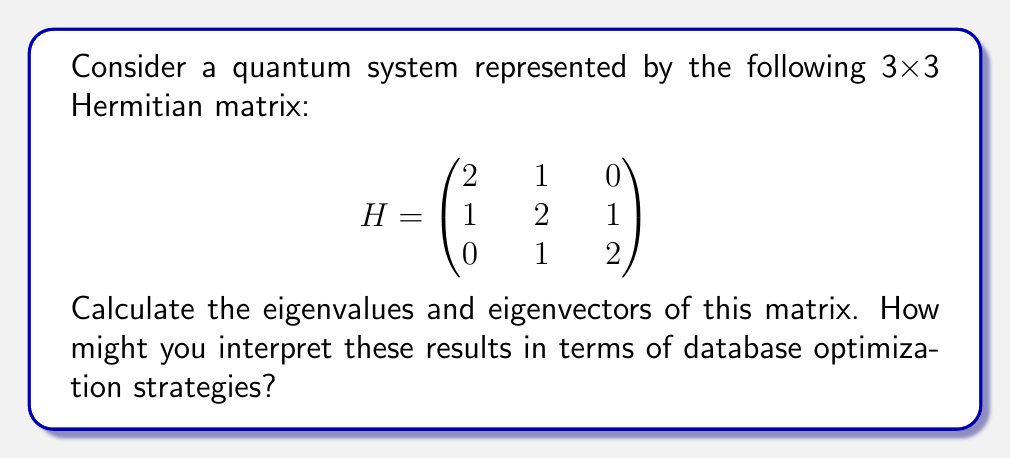Show me your answer to this math problem. To find the eigenvalues and eigenvectors, we'll follow these steps:

1) Find the characteristic equation:
   $\det(H - \lambda I) = 0$

   $$\begin{vmatrix}
   2-\lambda & 1 & 0 \\
   1 & 2-\lambda & 1 \\
   0 & 1 & 2-\lambda
   \end{vmatrix} = 0$$

2) Expand the determinant:
   $(2-\lambda)[(2-\lambda)^2 - 1] - 1(1-0) = 0$
   $(2-\lambda)[(2-\lambda)^2 - 1] - 1 = 0$
   $(2-\lambda)^3 - (2-\lambda) - 1 = 0$
   $\lambda^3 - 6\lambda^2 + 11\lambda - 6 = 0$

3) Solve the cubic equation. The roots are:
   $\lambda_1 = 2 - \sqrt{2}$
   $\lambda_2 = 2$
   $\lambda_3 = 2 + \sqrt{2}$

4) For each eigenvalue, solve $(H - \lambda I)v = 0$ to find the eigenvectors:

   For $\lambda_1 = 2 - \sqrt{2}$:
   $$\begin{pmatrix}
   \sqrt{2} & 1 & 0 \\
   1 & \sqrt{2} & 1 \\
   0 & 1 & \sqrt{2}
   \end{pmatrix}\begin{pmatrix}
   v_1 \\ v_2 \\ v_3
   \end{pmatrix} = \begin{pmatrix}
   0 \\ 0 \\ 0
   \end{pmatrix}$$

   Solving this gives: $v_1 = 1$, $v_2 = -\sqrt{2}$, $v_3 = 1$

   For $\lambda_2 = 2$:
   $$\begin{pmatrix}
   0 & 1 & 0 \\
   1 & 0 & 1 \\
   0 & 1 & 0
   \end{pmatrix}\begin{pmatrix}
   v_1 \\ v_2 \\ v_3
   \end{pmatrix} = \begin{pmatrix}
   0 \\ 0 \\ 0
   \end{pmatrix}$$

   Solving this gives: $v_1 = 1$, $v_2 = 0$, $v_3 = -1$

   For $\lambda_3 = 2 + \sqrt{2}$:
   $$\begin{pmatrix}
   -\sqrt{2} & 1 & 0 \\
   1 & -\sqrt{2} & 1 \\
   0 & 1 & -\sqrt{2}
   \end{pmatrix}\begin{pmatrix}
   v_1 \\ v_2 \\ v_3
   \end{pmatrix} = \begin{pmatrix}
   0 \\ 0 \\ 0
   \end{pmatrix}$$

   Solving this gives: $v_1 = 1$, $v_2 = \sqrt{2}$, $v_3 = 1$

5) Normalize the eigenvectors:

   $v_1 = \frac{1}{\sqrt{4-2\sqrt{2}}}(1, -\sqrt{2}, 1)^T$
   $v_2 = \frac{1}{\sqrt{2}}(1, 0, -1)^T$
   $v_3 = \frac{1}{\sqrt{4+2\sqrt{2}}}(1, \sqrt{2}, 1)^T$

Interpreting these results in terms of database optimization:
The eigenvalues represent the energy levels of the system, which could be analogous to the performance levels of different database operations. The eigenvectors represent the states that correspond to these energy levels, which could be thought of as the optimal configurations for achieving these performance levels. Just as in quantum mechanics where we seek to understand and manipulate these energy states, in database optimization, we aim to understand and optimize the performance states of our system.
Answer: Eigenvalues: $\lambda_1 = 2 - \sqrt{2}$, $\lambda_2 = 2$, $\lambda_3 = 2 + \sqrt{2}$
Eigenvectors: $v_1 = \frac{1}{\sqrt{4-2\sqrt{2}}}(1, -\sqrt{2}, 1)^T$, $v_2 = \frac{1}{\sqrt{2}}(1, 0, -1)^T$, $v_3 = \frac{1}{\sqrt{4+2\sqrt{2}}}(1, \sqrt{2}, 1)^T$ 